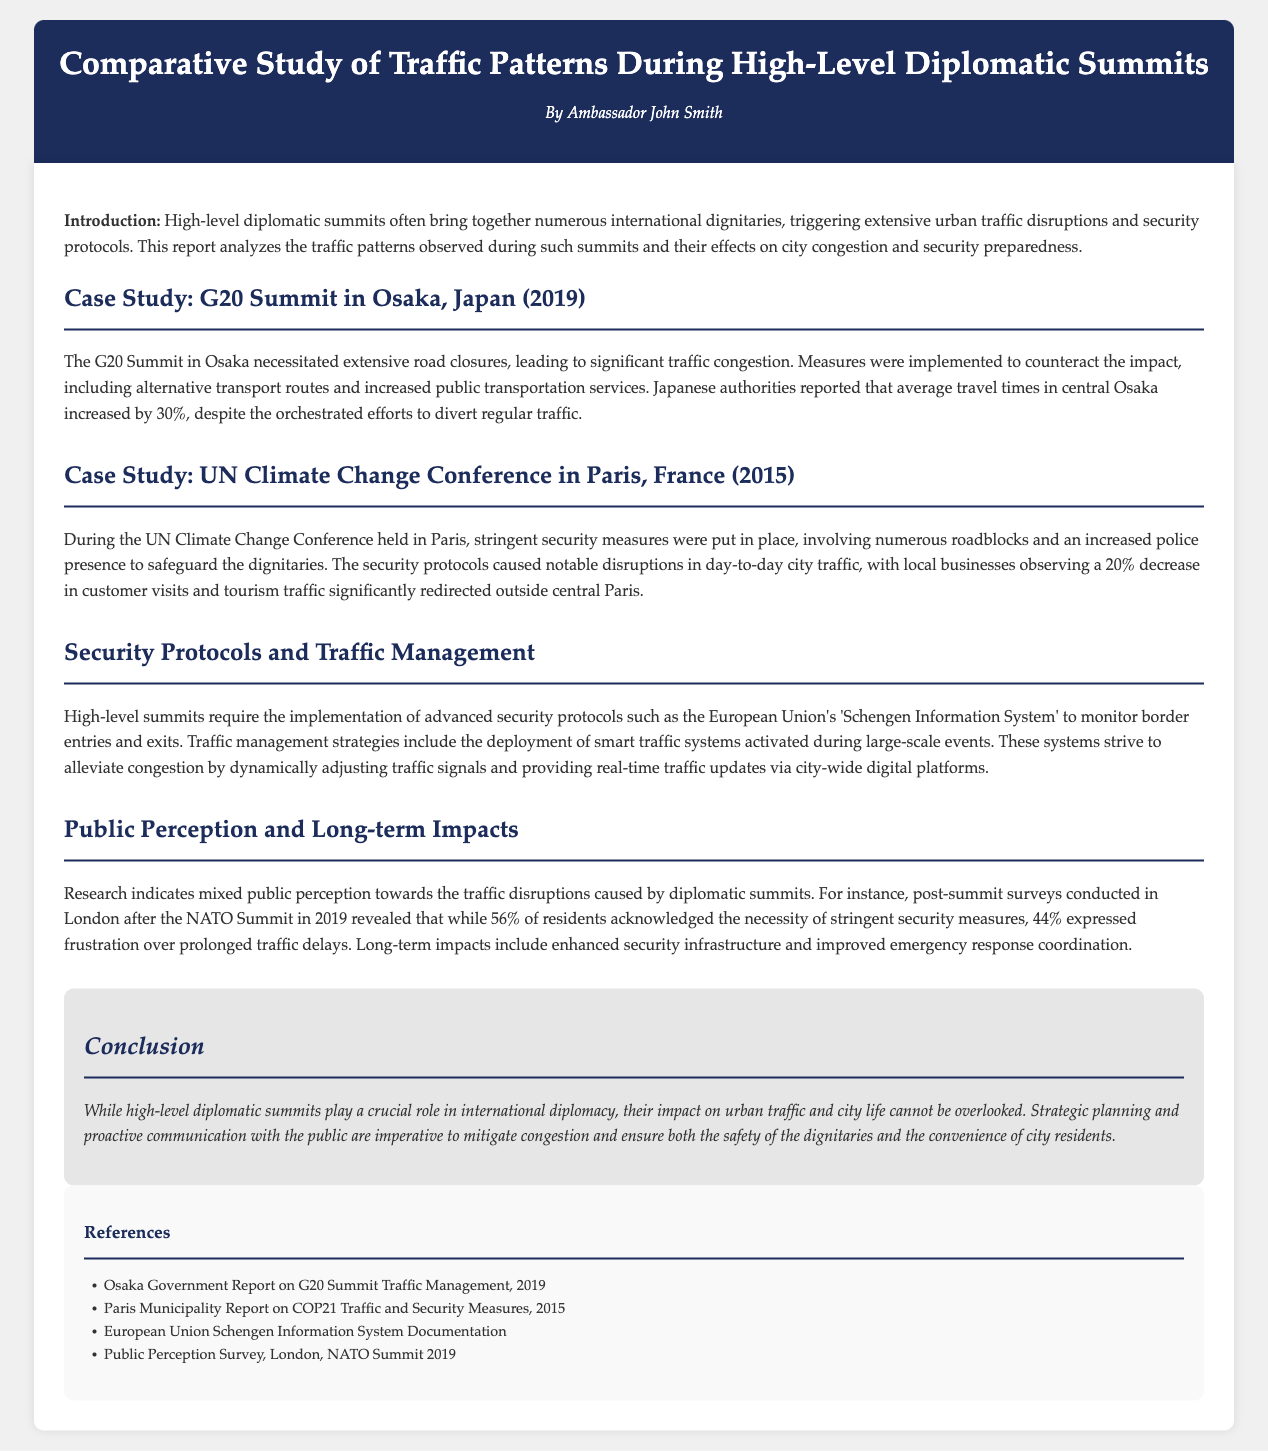What year did the G20 Summit take place in Osaka? The G20 Summit in Osaka occurred in 2019, as stated in the case study section of the report.
Answer: 2019 What was the average travel time increase in central Osaka during the G20 Summit? The report indicates that average travel times in central Osaka increased by 30% during the G20 Summit.
Answer: 30% What effect did the UN Climate Change Conference have on local businesses in Paris? The report mentions that local businesses observed a 20% decrease in customer visits during the conference.
Answer: 20% What advanced system is mentioned for monitoring border entries during high-level summits? The European Union's 'Schengen Information System' is referenced as a system for monitoring border entries.
Answer: Schengen Information System What percentage of London residents acknowledged the necessity of stringent security measures post-NATO Summit? According to the post-summit survey, 56% of London residents acknowledged the necessity of stringent security measures.
Answer: 56% What is a key long-term impact noted in the report due to high-level diplomatic summits? The report states that long-term impacts include enhanced security infrastructure and improved emergency response coordination.
Answer: Enhanced security infrastructure What type of planning is deemed imperative to mitigate congestion during summits? The conclusion emphasizes that strategic planning and proactive communication with the public are imperative.
Answer: Strategic planning What year did the UN Climate Change Conference occur in Paris? The report specifies that the UN Climate Change Conference took place in 2015.
Answer: 2015 